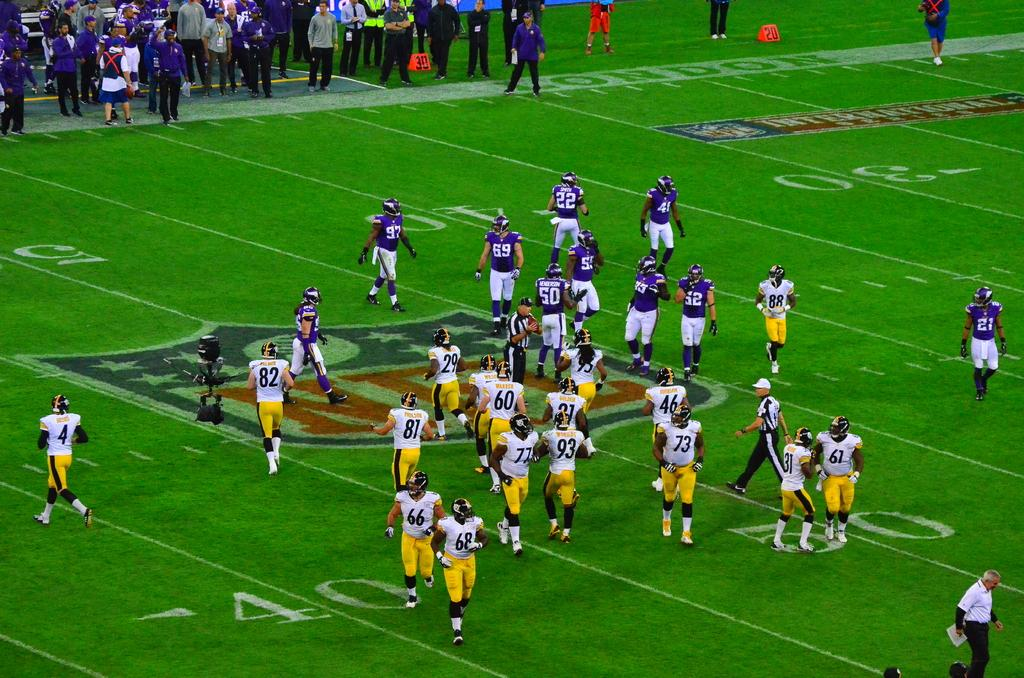What are the people in the foreground of the image doing? The people in the foreground of the image are walking and running on the grass. Where is the camera located in the image? The camera is present on the left side of the image. What can be seen at the top of the image? There are people walking and standing at the top of the image. How many legs does the goose have in the image? There is no goose present in the image, so it is not possible to determine the number of legs it might have. 